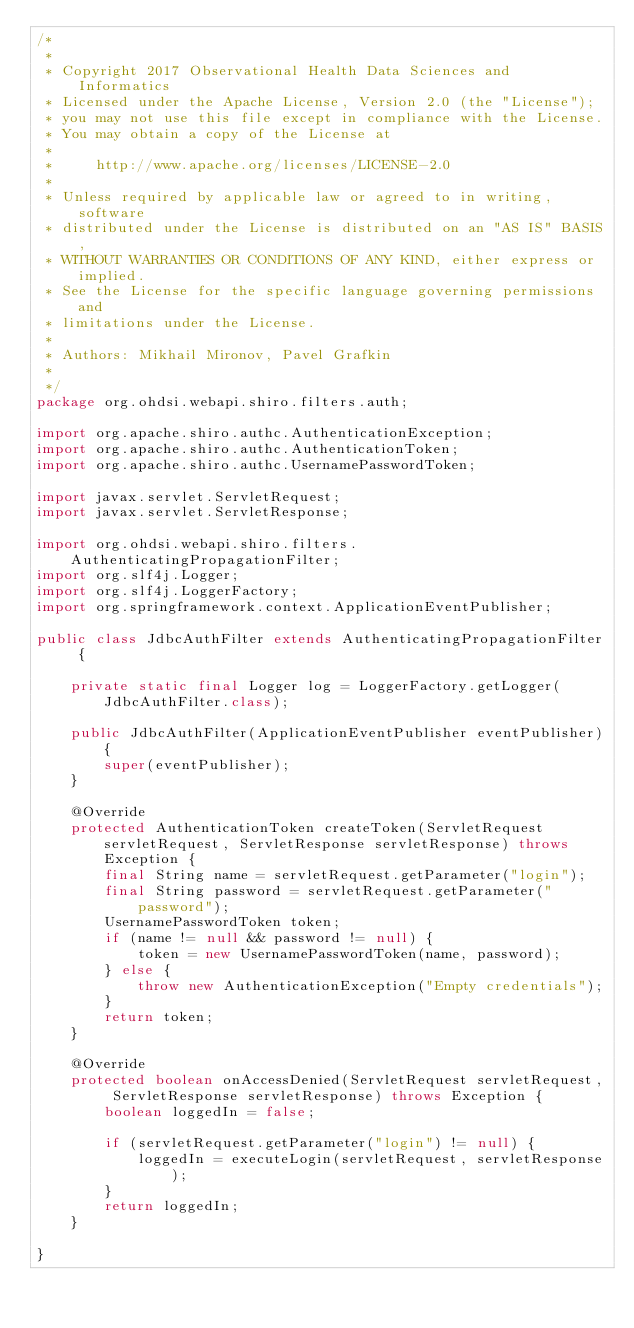Convert code to text. <code><loc_0><loc_0><loc_500><loc_500><_Java_>/*
 *
 * Copyright 2017 Observational Health Data Sciences and Informatics
 * Licensed under the Apache License, Version 2.0 (the "License");
 * you may not use this file except in compliance with the License.
 * You may obtain a copy of the License at
 *
 *     http://www.apache.org/licenses/LICENSE-2.0
 *
 * Unless required by applicable law or agreed to in writing, software
 * distributed under the License is distributed on an "AS IS" BASIS,
 * WITHOUT WARRANTIES OR CONDITIONS OF ANY KIND, either express or implied.
 * See the License for the specific language governing permissions and
 * limitations under the License.
 *
 * Authors: Mikhail Mironov, Pavel Grafkin
 *
 */
package org.ohdsi.webapi.shiro.filters.auth;

import org.apache.shiro.authc.AuthenticationException;
import org.apache.shiro.authc.AuthenticationToken;
import org.apache.shiro.authc.UsernamePasswordToken;

import javax.servlet.ServletRequest;
import javax.servlet.ServletResponse;

import org.ohdsi.webapi.shiro.filters.AuthenticatingPropagationFilter;
import org.slf4j.Logger;
import org.slf4j.LoggerFactory;
import org.springframework.context.ApplicationEventPublisher;

public class JdbcAuthFilter extends AuthenticatingPropagationFilter {

    private static final Logger log = LoggerFactory.getLogger(JdbcAuthFilter.class);

    public JdbcAuthFilter(ApplicationEventPublisher eventPublisher){
        super(eventPublisher);
    }

    @Override
    protected AuthenticationToken createToken(ServletRequest servletRequest, ServletResponse servletResponse) throws Exception {
        final String name = servletRequest.getParameter("login");
        final String password = servletRequest.getParameter("password");
        UsernamePasswordToken token;
        if (name != null && password != null) {
            token = new UsernamePasswordToken(name, password);
        } else {
            throw new AuthenticationException("Empty credentials");
        }
        return token;
    }

    @Override
    protected boolean onAccessDenied(ServletRequest servletRequest, ServletResponse servletResponse) throws Exception {
        boolean loggedIn = false;

        if (servletRequest.getParameter("login") != null) {
            loggedIn = executeLogin(servletRequest, servletResponse);
        }
        return loggedIn;
    }

}
</code> 